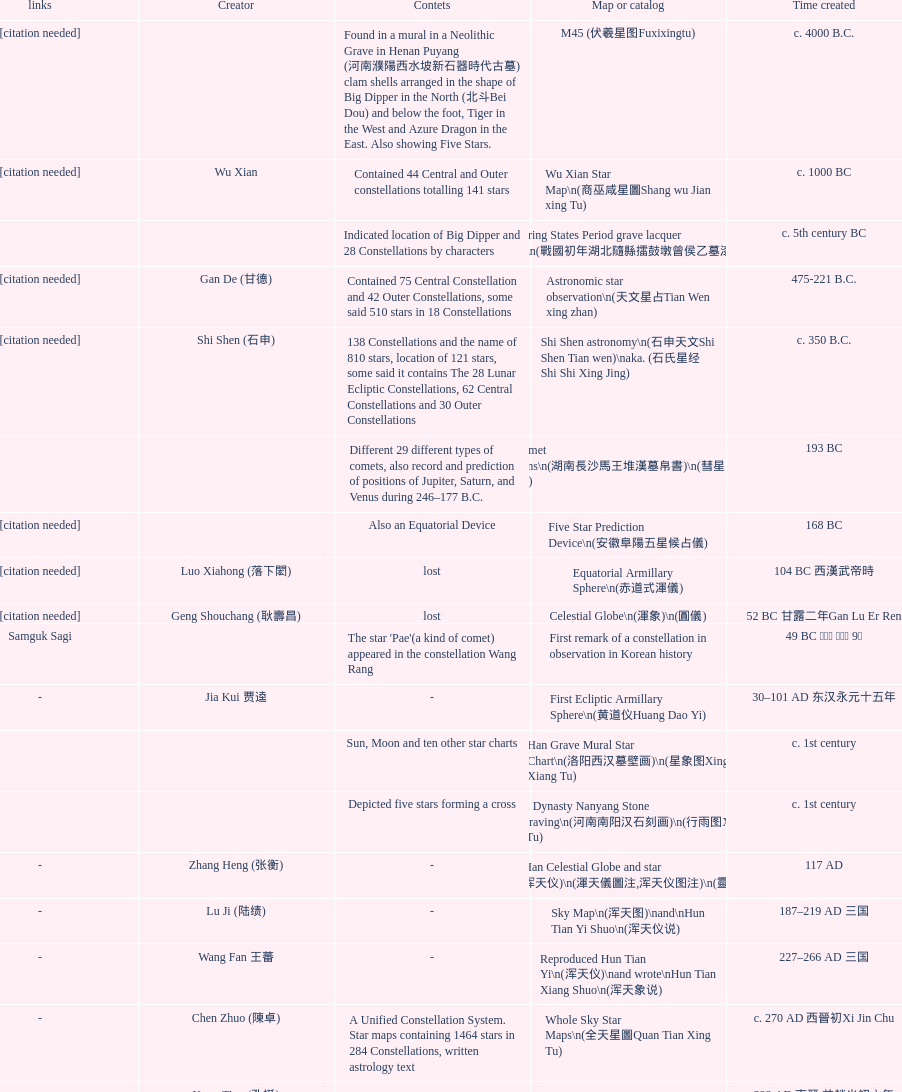What is the name of the oldest map/catalog? M45. 